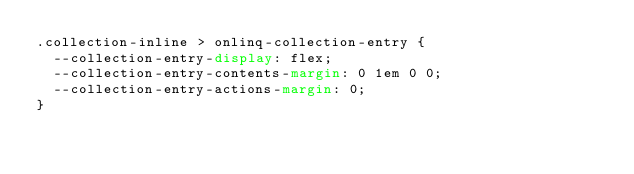<code> <loc_0><loc_0><loc_500><loc_500><_CSS_>.collection-inline > onlinq-collection-entry {
  --collection-entry-display: flex;
  --collection-entry-contents-margin: 0 1em 0 0;
  --collection-entry-actions-margin: 0;
}
</code> 